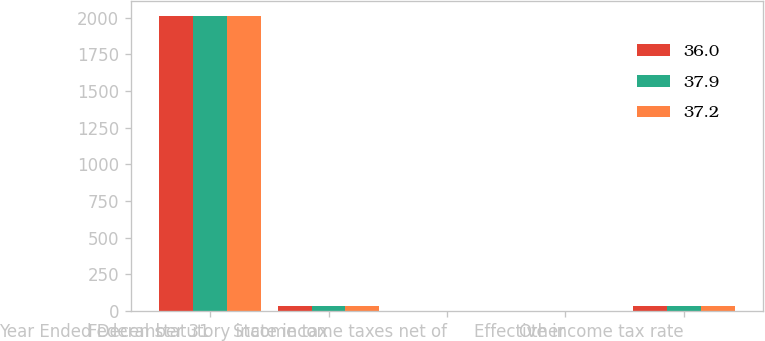Convert chart to OTSL. <chart><loc_0><loc_0><loc_500><loc_500><stacked_bar_chart><ecel><fcel>Year Ended December 31<fcel>Federal statutory income tax<fcel>State income taxes net of<fcel>Other<fcel>Effective income tax rate<nl><fcel>36<fcel>2013<fcel>35<fcel>2.3<fcel>0.1<fcel>37.2<nl><fcel>37.9<fcel>2012<fcel>35<fcel>1.2<fcel>0.2<fcel>36<nl><fcel>37.2<fcel>2011<fcel>35<fcel>2.5<fcel>0.4<fcel>37.9<nl></chart> 